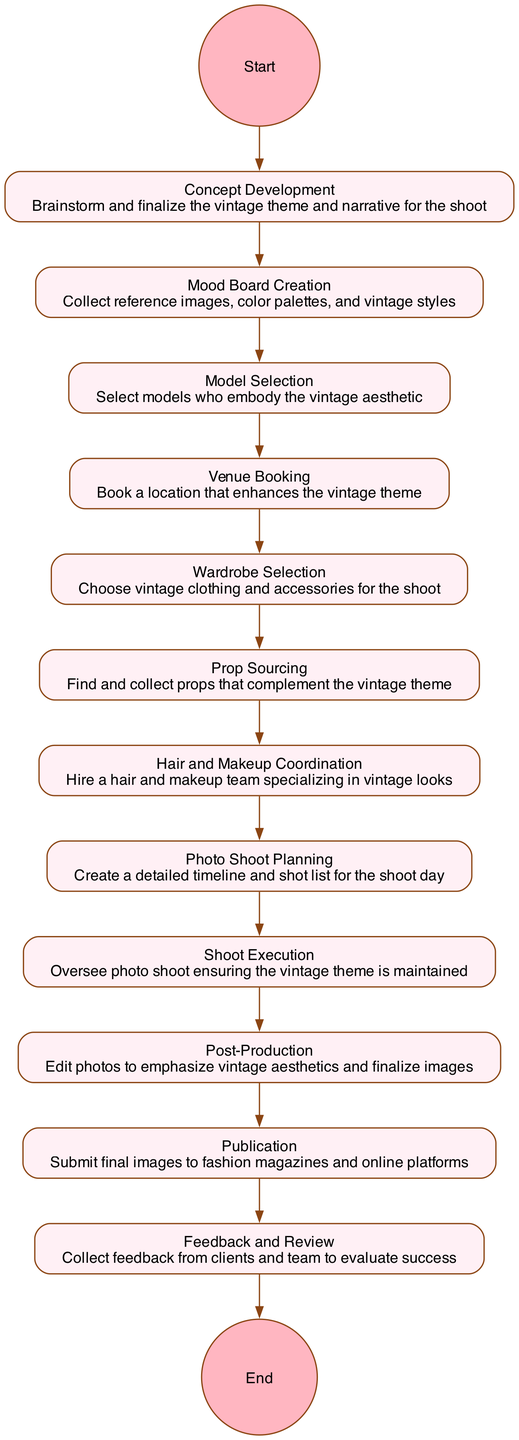What is the first activity in the diagram? The diagram starts with the 'Start' node, and the first activity is 'Concept Development', which is the first connected node following the start.
Answer: Concept Development How many total activities are there in the diagram? By counting each distinct activity node connected in the diagram, there are a total of 11 activities listed before reaching the end node.
Answer: 11 Which activity follows 'Model Selection'? In the flow of the diagram, 'Model Selection' is followed by 'Venue Booking', making it the next step in the sequence.
Answer: Venue Booking What is the last activity before publication? The last activity before 'Publication' is 'Post-Production', as it directly precedes the submission of final images.
Answer: Post-Production Which two activities are connected directly by an edge? Each activity is connected by edges, for example, 'Mood Board Creation' is directly connected to 'Model Selection' and they are in sequential arrangement.
Answer: Mood Board Creation, Model Selection What activity occurs immediately after 'Shoot Execution'? The flow indicates that 'Post-Production' occurs immediately following 'Shoot Execution', making it the next action in the process.
Answer: Post-Production What role does the 'Feedback and Review' activity have in the overall process? 'Feedback and Review' serves as the concluding activity, gathering insights from clients and the team regarding the success of the photo shoot, which follows 'Publication'.
Answer: Gather insights Which activity involves sourcing props? The activity specifically tasked with sourcing props is labeled as 'Prop Sourcing', making it clear that this is its designated focus within the process.
Answer: Prop Sourcing How many phases are there from 'Concept Development' to 'Publication'? The phases or activities from 'Concept Development' to 'Publication' consist of 9 distinct steps, following the sequential flow from start through to publication.
Answer: 9 